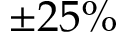Convert formula to latex. <formula><loc_0><loc_0><loc_500><loc_500>\pm 2 5 \%</formula> 